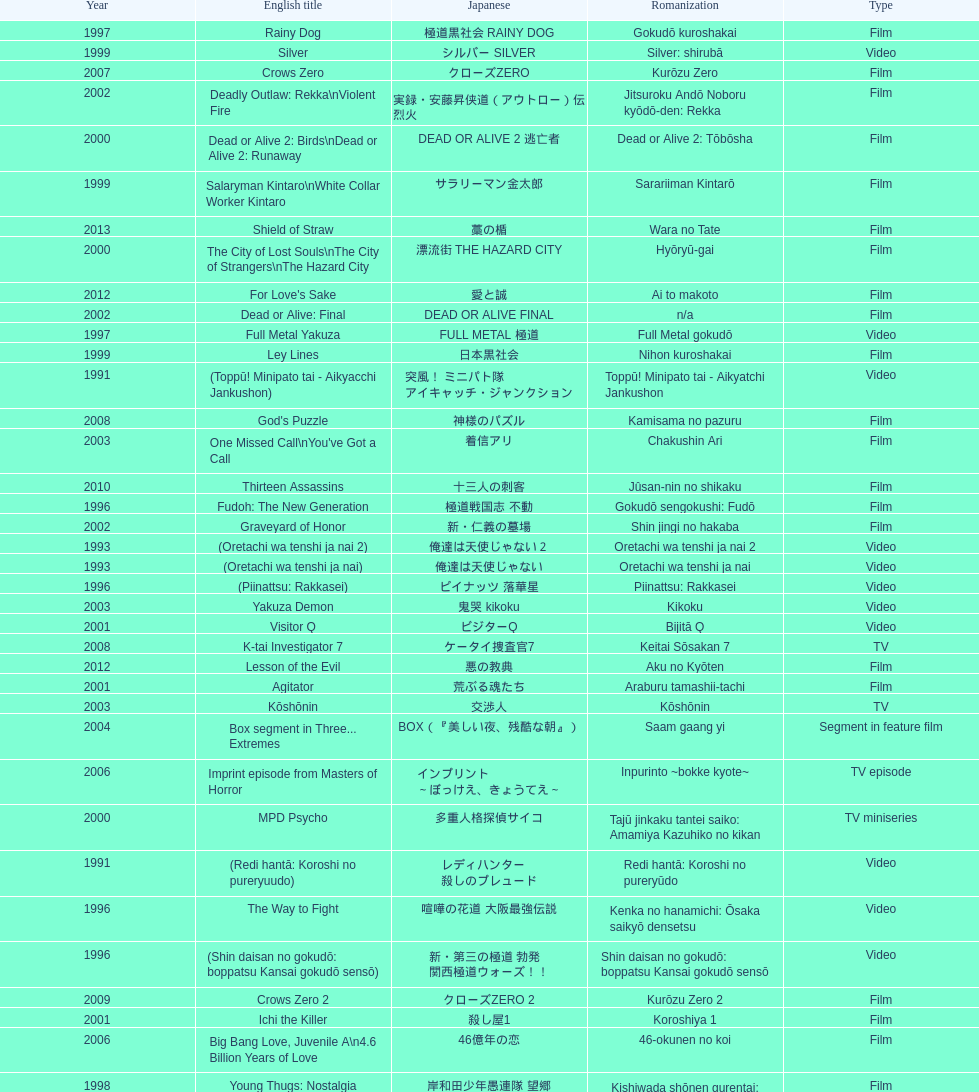Was shinjuku triad society a film or tv release? Film. I'm looking to parse the entire table for insights. Could you assist me with that? {'header': ['Year', 'English title', 'Japanese', 'Romanization', 'Type'], 'rows': [['1997', 'Rainy Dog', '極道黒社会 RAINY DOG', 'Gokudō kuroshakai', 'Film'], ['1999', 'Silver', 'シルバー SILVER', 'Silver: shirubā', 'Video'], ['2007', 'Crows Zero', 'クローズZERO', 'Kurōzu Zero', 'Film'], ['2002', 'Deadly Outlaw: Rekka\\nViolent Fire', '実録・安藤昇侠道（アウトロー）伝 烈火', 'Jitsuroku Andō Noboru kyōdō-den: Rekka', 'Film'], ['2000', 'Dead or Alive 2: Birds\\nDead or Alive 2: Runaway', 'DEAD OR ALIVE 2 逃亡者', 'Dead or Alive 2: Tōbōsha', 'Film'], ['1999', 'Salaryman Kintaro\\nWhite Collar Worker Kintaro', 'サラリーマン金太郎', 'Sarariiman Kintarō', 'Film'], ['2013', 'Shield of Straw', '藁の楯', 'Wara no Tate', 'Film'], ['2000', 'The City of Lost Souls\\nThe City of Strangers\\nThe Hazard City', '漂流街 THE HAZARD CITY', 'Hyōryū-gai', 'Film'], ['2012', "For Love's Sake", '愛と誠', 'Ai to makoto', 'Film'], ['2002', 'Dead or Alive: Final', 'DEAD OR ALIVE FINAL', 'n/a', 'Film'], ['1997', 'Full Metal Yakuza', 'FULL METAL 極道', 'Full Metal gokudō', 'Video'], ['1999', 'Ley Lines', '日本黒社会', 'Nihon kuroshakai', 'Film'], ['1991', '(Toppū! Minipato tai - Aikyacchi Jankushon)', '突風！ ミニパト隊 アイキャッチ・ジャンクション', 'Toppū! Minipato tai - Aikyatchi Jankushon', 'Video'], ['2008', "God's Puzzle", '神様のパズル', 'Kamisama no pazuru', 'Film'], ['2003', "One Missed Call\\nYou've Got a Call", '着信アリ', 'Chakushin Ari', 'Film'], ['2010', 'Thirteen Assassins', '十三人の刺客', 'Jûsan-nin no shikaku', 'Film'], ['1996', 'Fudoh: The New Generation', '極道戦国志 不動', 'Gokudō sengokushi: Fudō', 'Film'], ['2002', 'Graveyard of Honor', '新・仁義の墓場', 'Shin jingi no hakaba', 'Film'], ['1993', '(Oretachi wa tenshi ja nai 2)', '俺達は天使じゃない２', 'Oretachi wa tenshi ja nai 2', 'Video'], ['1993', '(Oretachi wa tenshi ja nai)', '俺達は天使じゃない', 'Oretachi wa tenshi ja nai', 'Video'], ['1996', '(Piinattsu: Rakkasei)', 'ピイナッツ 落華星', 'Piinattsu: Rakkasei', 'Video'], ['2003', 'Yakuza Demon', '鬼哭 kikoku', 'Kikoku', 'Video'], ['2001', 'Visitor Q', 'ビジターQ', 'Bijitā Q', 'Video'], ['2008', 'K-tai Investigator 7', 'ケータイ捜査官7', 'Keitai Sōsakan 7', 'TV'], ['2012', 'Lesson of the Evil', '悪の教典', 'Aku no Kyōten', 'Film'], ['2001', 'Agitator', '荒ぶる魂たち', 'Araburu tamashii-tachi', 'Film'], ['2003', 'Kōshōnin', '交渉人', 'Kōshōnin', 'TV'], ['2004', 'Box segment in Three... Extremes', 'BOX（『美しい夜、残酷な朝』）', 'Saam gaang yi', 'Segment in feature film'], ['2006', 'Imprint episode from Masters of Horror', 'インプリント ～ぼっけえ、きょうてえ～', 'Inpurinto ~bokke kyote~', 'TV episode'], ['2000', 'MPD Psycho', '多重人格探偵サイコ', 'Tajū jinkaku tantei saiko: Amamiya Kazuhiko no kikan', 'TV miniseries'], ['1991', '(Redi hantā: Koroshi no pureryuudo)', 'レディハンター 殺しのプレュード', 'Redi hantā: Koroshi no pureryūdo', 'Video'], ['1996', 'The Way to Fight', '喧嘩の花道 大阪最強伝説', 'Kenka no hanamichi: Ōsaka saikyō densetsu', 'Video'], ['1996', '(Shin daisan no gokudō: boppatsu Kansai gokudō sensō)', '新・第三の極道 勃発 関西極道ウォーズ！！', 'Shin daisan no gokudō: boppatsu Kansai gokudō sensō', 'Video'], ['2009', 'Crows Zero 2', 'クローズZERO 2', 'Kurōzu Zero 2', 'Film'], ['2001', 'Ichi the Killer', '殺し屋1', 'Koroshiya 1', 'Film'], ['2006', 'Big Bang Love, Juvenile A\\n4.6 Billion Years of Love', '46億年の恋', '46-okunen no koi', 'Film'], ['1998', 'Young Thugs: Nostalgia', '岸和田少年愚連隊 望郷', 'Kishiwada shōnen gurentai: Bōkyō', 'Film'], ['1995', '(Shura no mokushiroku 2: Bodigādo Kiba)', '修羅の黙示録2 ボディーガード牙', 'Shura no mokushiroku 2: Bodigādo Kiba', 'Video'], ['2004', 'Zebraman', 'ゼブラーマン', 'Zeburāman', 'Film'], ['1996', '(Jingi naki yabō)', '仁義なき野望', 'Jingi naki yabō', 'Video'], ['1999', 'Dead or Alive', 'DEAD OR ALIVE 犯罪者', 'Dead or Alive: Hanzaisha', 'Film'], ['2002', '(Onna kunishū ikki)', 'おんな 国衆一揆', 'Onna kunishū ikki', '(unknown)'], ['2007', 'Like a Dragon', '龍が如く 劇場版', 'Ryu ga Gotoku Gekijōban', 'Film'], ['2011', 'Hara-Kiri: Death of a Samurai', '一命', 'Ichimei', 'Film'], ['2002', 'Shangri-La', '金融破滅ニッポン 桃源郷の人々', "Kin'yū hametsu Nippon: Tōgenkyō no hito-bito", 'Film'], ['2006', 'Waru', 'WARU', 'Waru', 'Film'], ['2003', 'The Man in White', '許されざる者', 'Yurusarezaru mono', 'Film'], ['2005', 'The Great Yokai War', '妖怪大戦争', 'Yokai Daisenso', 'Film'], ['2007', 'Zatoichi', '座頭市', 'Zatōichi', 'Stageplay'], ['1994', '(Shura no mokushiroku: Bodigādo Kiba)', '修羅の黙示録 ボディーガード牙', 'Shura no mokushiroku: Bodigādo Kiba', 'Video'], ['1996', '(Shin daisan no gokudō II)', '新・第三の極道II', 'Shin daisan no gokudō II', 'Video'], ['2002', 'Pāto-taimu tantei', 'パートタイム探偵', 'Pāto-taimu tantei', 'TV series'], ['1999', 'Audition', 'オーディション', 'Ōdishon', 'Film'], ['2002', 'Sabu', 'SABU さぶ', 'Sabu', 'TV'], ['2007', 'Sukiyaki Western Django', 'スキヤキ・ウエスタン ジャンゴ', 'Sukiyaki wesutān jango', 'Film'], ['2002', 'Pandōra', 'パンドーラ', 'Pandōra', 'Music video'], ['2012', 'Ace Attorney', '逆転裁判', 'Gyakuten Saiban', 'Film'], ['1995', 'Shinjuku Triad Society', '新宿黒社会 チャイナ マフィア戦争', 'Shinjuku kuroshakai: Chaina mafia sensō', 'Film'], ['1998', 'Andromedia', 'アンドロメデイア andromedia', 'Andoromedia', 'Film'], ['2001', '(Kikuchi-jō monogatari: sakimori-tachi no uta)', '鞠智城物語 防人たちの唄', 'Kikuchi-jō monogatari: sakimori-tachi no uta', 'Film'], ['2001', 'The Happiness of the Katakuris', 'カタクリ家の幸福', 'Katakuri-ke no kōfuku', 'Film'], ['1999', 'Man, A Natural Girl', '天然少女萬', 'Tennen shōjo Man', 'TV'], ['2001', 'Family', 'FAMILY', 'n/a', 'Film'], ['2000', "The Making of 'Gemini'", '(unknown)', "Tsukamoto Shin'ya ga Ranpo suru", 'TV documentary'], ['2001', '(Zuiketsu gensō: Tonkararin yume densetsu)', '隧穴幻想 トンカラリン夢伝説', 'Zuiketsu gensō: Tonkararin yume densetsu', 'Film'], ['1999', 'Man, Next Natural Girl: 100 Nights In Yokohama\\nN-Girls vs Vampire', '天然少女萬NEXT 横浜百夜篇', 'Tennen shōjo Man next: Yokohama hyaku-ya hen', 'TV'], ['1995', '(Daisan no gokudō)', '第三の極道', 'Daisan no gokudō', 'Video'], ['2009', 'Yatterman', 'ヤッターマン', 'Yattaaman', 'Film'], ['2000', 'The Guys from Paradise', '天国から来た男たち', 'Tengoku kara kita otoko-tachi', 'Film'], ['2010', 'Zebraman 2: Attack on Zebra City', 'ゼブラーマン -ゼブラシティの逆襲', 'Zeburāman -Zebura Shiti no Gyakushū', 'Film'], ['1991', '(Shissō Feraari 250 GTO / Rasuto ran: Ai to uragiri no hyaku-oku en)', '疾走フェラーリ250GTO/ラスト・ラン～愛と裏切りの百億円', 'Shissō Feraari 250 GTO / Rasuto ran: Ai to uragiri no hyaku-oku en\\nShissō Feraari 250 GTO / Rasuto ran: Ai to uragiri no ¥10 000 000 000', 'TV'], ['2007', 'Detective Story', '探偵物語', 'Tantei monogatari', 'Film'], ['1998', 'The Bird People in China', '中国の鳥人', 'Chûgoku no chôjin', 'Film'], ['2003', 'Gozu', '極道恐怖大劇場 牛頭 GOZU', 'Gokudō kyōfu dai-gekijō: Gozu', 'Film'], ['1997', 'Young Thugs: Innocent Blood', '岸和田少年愚連隊 血煙り純情篇', 'Kishiwada shōnen gurentai: Chikemuri junjō-hen', 'Film'], ['1994', 'Shinjuku Outlaw', '新宿アウトロー', 'Shinjuku autorou', 'Video'], ['2004', 'Pāto-taimu tantei 2', 'パートタイム探偵2', 'Pāto-taimu tantei 2', 'TV'], ['2011', 'Ninja Kids!!!', '忍たま乱太郎', 'Nintama Rantarō', 'Film'], ['2006', 'Waru: kanketsu-hen', '', 'Waru: kanketsu-hen', 'Video'], ['1995', 'Osaka Tough Guys', 'なにわ遊侠伝', 'Naniwa yūkyōden', 'Video'], ['2005', 'Ultraman Max', 'ウルトラマンマックス', 'Urutoraman Makkusu', 'Episodes 15 and 16 from TV tokusatsu series'], ['2004', 'Izo', 'IZO', 'IZO', 'Film'], ['1997', '(Jingi naki yabō 2)', '仁義なき野望2', 'Jingi naki yabō 2', 'Video'], ['1998', 'Blues Harp', 'BLUES HARP', 'n/a', 'Film'], ['2013', 'The Mole Song: Undercover Agent Reiji', '土竜の唄\u3000潜入捜査官 REIJI', 'Mogura no uta – sennyu sosakan: Reiji', 'Film'], ['2006', 'Sun Scarred', '太陽の傷', 'Taiyo no kizu', 'Film'], ['1993', 'Bodyguard Kiba', 'ボディガード牙', 'Bodigādo Kiba', 'Video'], ['1992', 'A Human Murder Weapon', '人間兇器 愛と怒りのリング', 'Ningen kyōki: Ai to ikari no ringu', 'Video']]} 